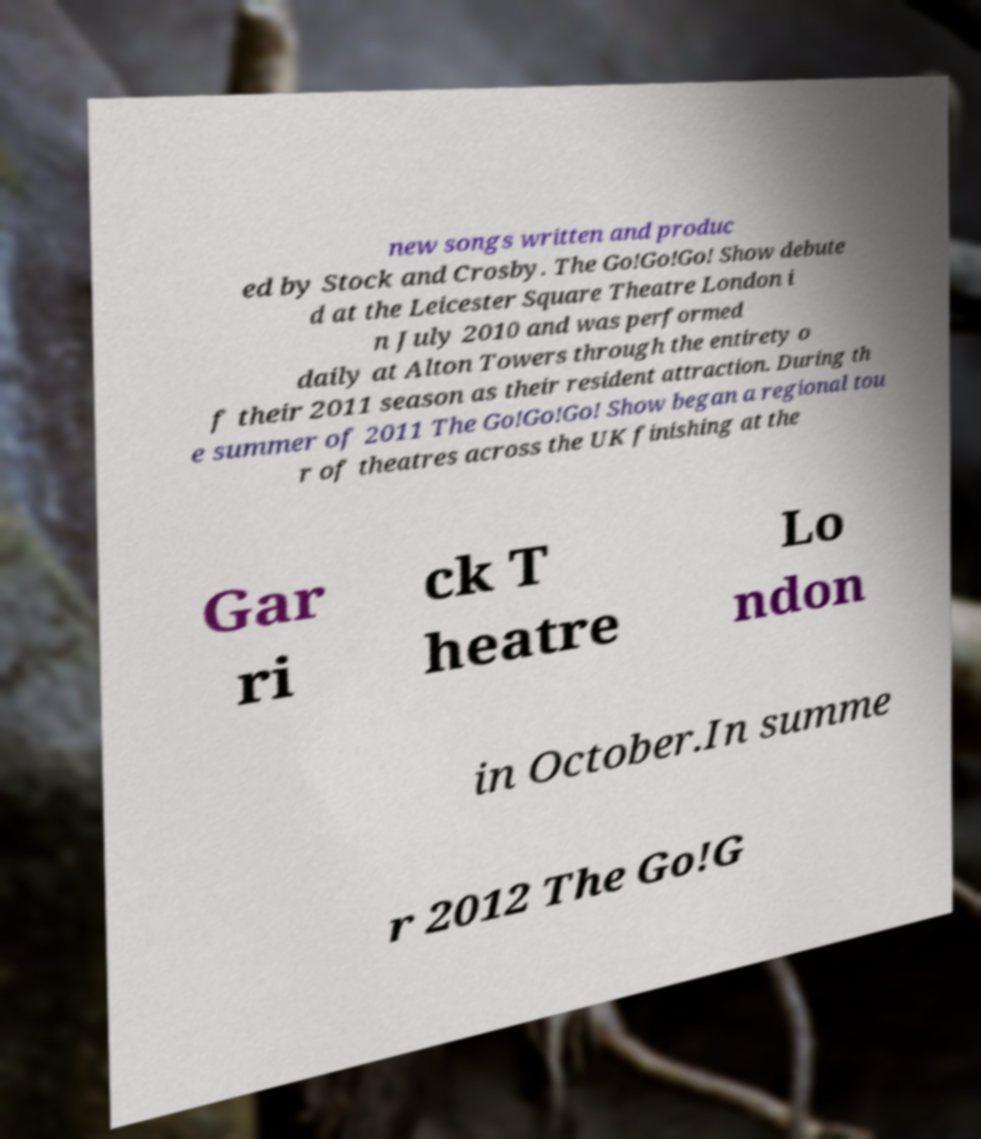Please read and relay the text visible in this image. What does it say? new songs written and produc ed by Stock and Crosby. The Go!Go!Go! Show debute d at the Leicester Square Theatre London i n July 2010 and was performed daily at Alton Towers through the entirety o f their 2011 season as their resident attraction. During th e summer of 2011 The Go!Go!Go! Show began a regional tou r of theatres across the UK finishing at the Gar ri ck T heatre Lo ndon in October.In summe r 2012 The Go!G 